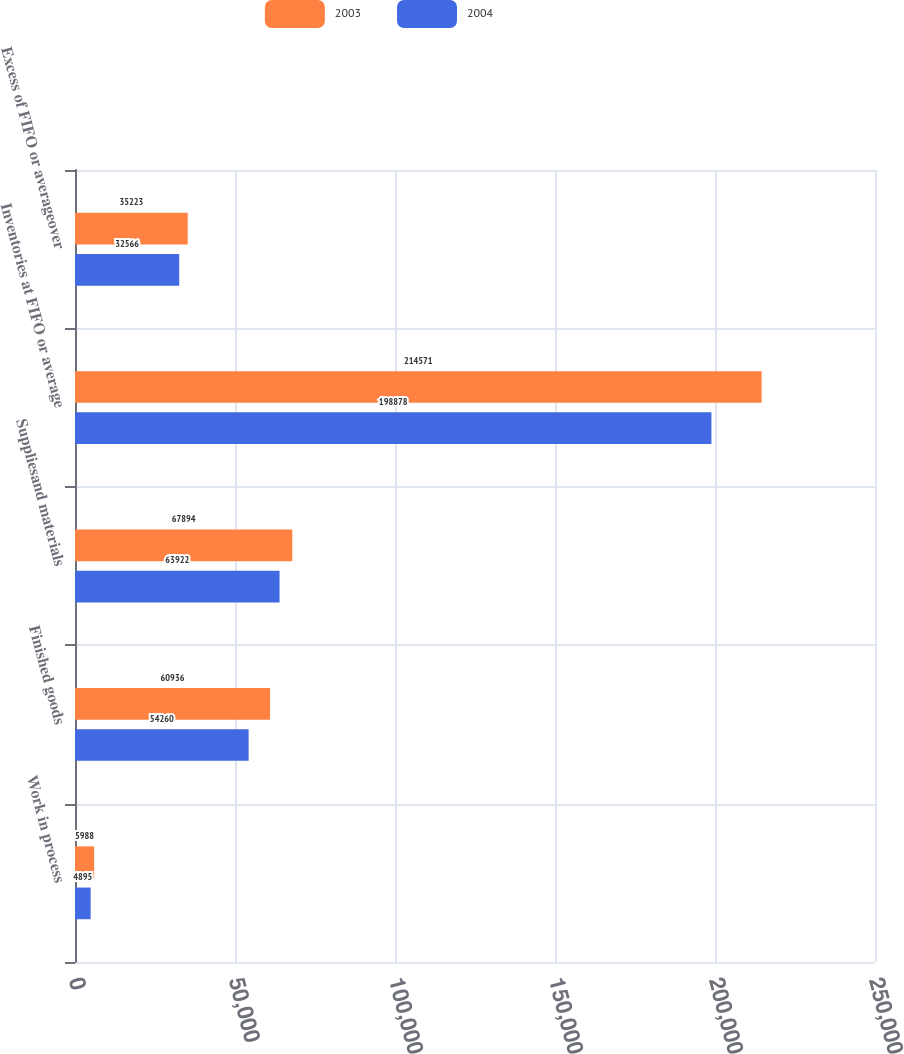Convert chart. <chart><loc_0><loc_0><loc_500><loc_500><stacked_bar_chart><ecel><fcel>Work in process<fcel>Finished goods<fcel>Suppliesand materials<fcel>Inventories at FIFO or average<fcel>Excess of FIFO or averageover<nl><fcel>2003<fcel>5988<fcel>60936<fcel>67894<fcel>214571<fcel>35223<nl><fcel>2004<fcel>4895<fcel>54260<fcel>63922<fcel>198878<fcel>32566<nl></chart> 